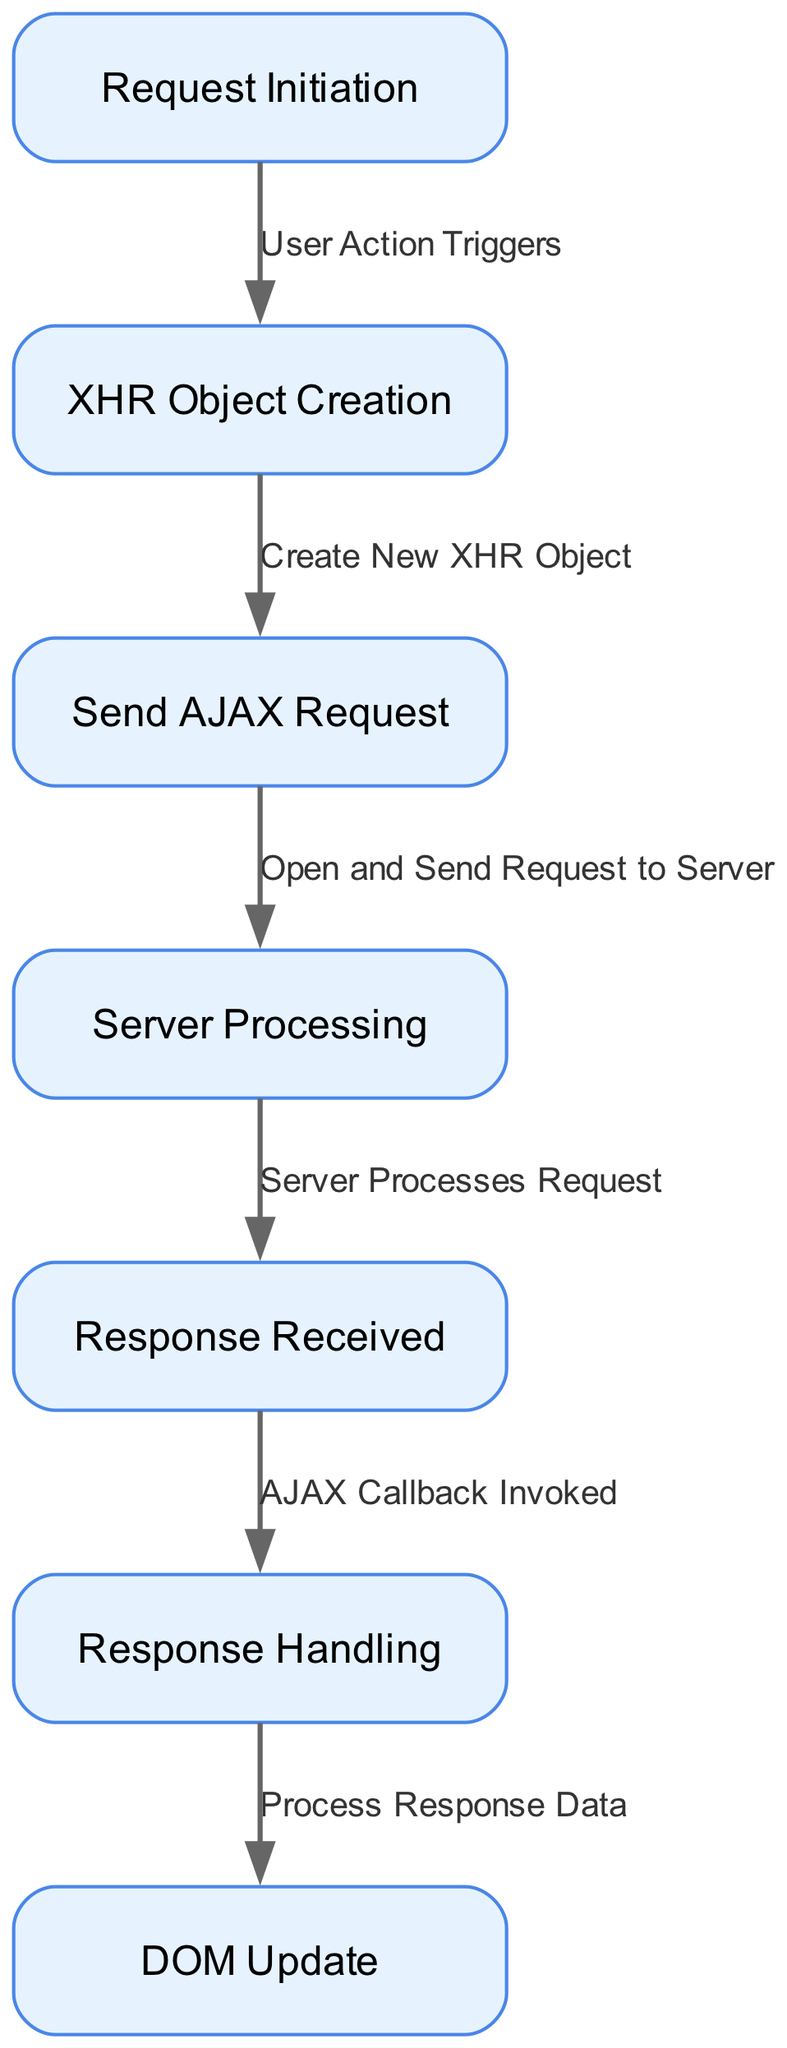What is the first step in the AJAX request lifecycle? The first step is "Request Initiation", which indicates that a user action has triggered the AJAX process to begin.
Answer: Request Initiation How many nodes are present in the diagram? The diagram lists seven distinct nodes that define various steps in the AJAX request lifecycle.
Answer: Seven What relationship exists between "Send AJAX Request" and "Server Processing"? The relationship is defined by the edge labeled "Open and Send Request to Server", describing the action that occurs between these two nodes in the lifecycle.
Answer: Open and Send Request to Server What is the last step depicted in the diagram? The last step is "DOM Update", where the final response handling results in the update of the document object model.
Answer: DOM Update Which node is directly linked to "Response Received"? The node directly linked to "Response Received" is "Response Handling", indicating the next phase after a response is received.
Answer: Response Handling What step occurs immediately after "Server Processing"? The step that follows "Server Processing" is "Response Received", indicating the completion of server-side processing and the return of data.
Answer: Response Received Which node represents the user-triggered action? The node "Request Initiation" represents the action triggered by the user, which starts the AJAX request.
Answer: Request Initiation Which edge describes the process of creating a new XHR object? The edge labeled "Create New XHR Object" describes the action that transitions from "XHR Object Creation" to "Send AJAX Request".
Answer: Create New XHR Object What follows after "AJAX Callback Invoked"? The step that follows "AJAX Callback Invoked" is "Response Handling", indicating that it is time to process the data received from the server.
Answer: Response Handling 